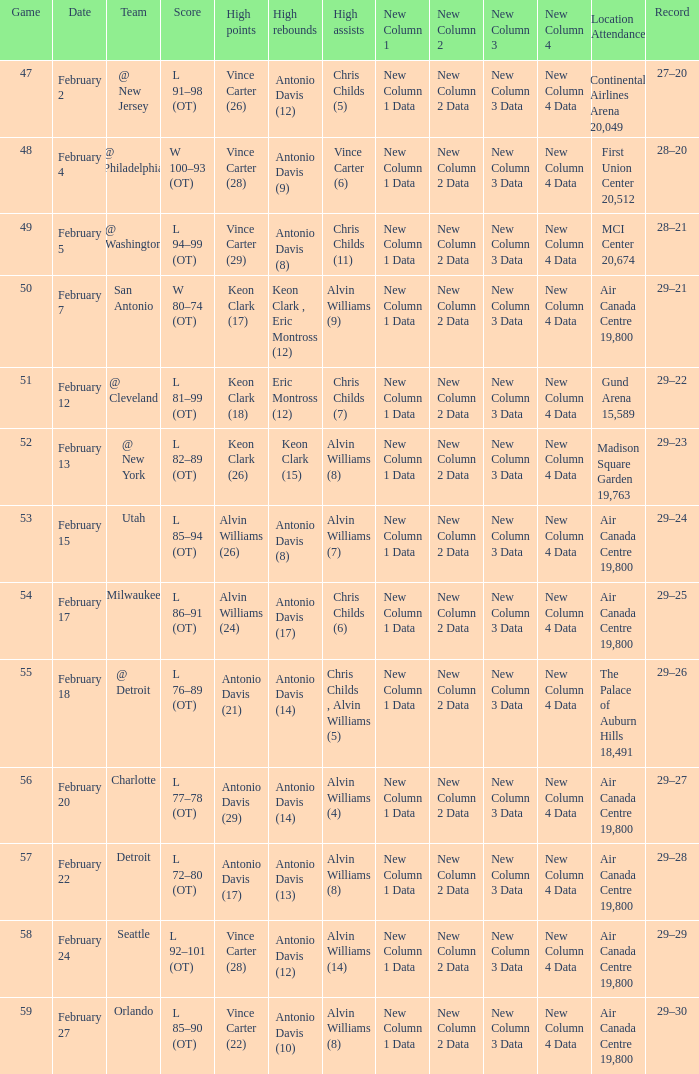What is the Record when the high rebounds was Antonio Davis (9)? 28–20. Could you parse the entire table as a dict? {'header': ['Game', 'Date', 'Team', 'Score', 'High points', 'High rebounds', 'High assists', 'New Column 1', 'New Column 2', 'New Column 3', 'New Column 4', 'Location Attendance', 'Record'], 'rows': [['47', 'February 2', '@ New Jersey', 'L 91–98 (OT)', 'Vince Carter (26)', 'Antonio Davis (12)', 'Chris Childs (5)', 'New Column 1 Data', 'New Column 2 Data', 'New Column 3 Data', 'New Column 4 Data', 'Continental Airlines Arena 20,049', '27–20'], ['48', 'February 4', '@ Philadelphia', 'W 100–93 (OT)', 'Vince Carter (28)', 'Antonio Davis (9)', 'Vince Carter (6)', 'New Column 1 Data', 'New Column 2 Data', 'New Column 3 Data', 'New Column 4 Data', 'First Union Center 20,512', '28–20'], ['49', 'February 5', '@ Washington', 'L 94–99 (OT)', 'Vince Carter (29)', 'Antonio Davis (8)', 'Chris Childs (11)', 'New Column 1 Data', 'New Column 2 Data', 'New Column 3 Data', 'New Column 4 Data', 'MCI Center 20,674', '28–21'], ['50', 'February 7', 'San Antonio', 'W 80–74 (OT)', 'Keon Clark (17)', 'Keon Clark , Eric Montross (12)', 'Alvin Williams (9)', 'New Column 1 Data', 'New Column 2 Data', 'New Column 3 Data', 'New Column 4 Data', 'Air Canada Centre 19,800', '29–21'], ['51', 'February 12', '@ Cleveland', 'L 81–99 (OT)', 'Keon Clark (18)', 'Eric Montross (12)', 'Chris Childs (7)', 'New Column 1 Data', 'New Column 2 Data', 'New Column 3 Data', 'New Column 4 Data', 'Gund Arena 15,589', '29–22'], ['52', 'February 13', '@ New York', 'L 82–89 (OT)', 'Keon Clark (26)', 'Keon Clark (15)', 'Alvin Williams (8)', 'New Column 1 Data', 'New Column 2 Data', 'New Column 3 Data', 'New Column 4 Data', 'Madison Square Garden 19,763', '29–23'], ['53', 'February 15', 'Utah', 'L 85–94 (OT)', 'Alvin Williams (26)', 'Antonio Davis (8)', 'Alvin Williams (7)', 'New Column 1 Data', 'New Column 2 Data', 'New Column 3 Data', 'New Column 4 Data', 'Air Canada Centre 19,800', '29–24'], ['54', 'February 17', 'Milwaukee', 'L 86–91 (OT)', 'Alvin Williams (24)', 'Antonio Davis (17)', 'Chris Childs (6)', 'New Column 1 Data', 'New Column 2 Data', 'New Column 3 Data', 'New Column 4 Data', 'Air Canada Centre 19,800', '29–25'], ['55', 'February 18', '@ Detroit', 'L 76–89 (OT)', 'Antonio Davis (21)', 'Antonio Davis (14)', 'Chris Childs , Alvin Williams (5)', 'New Column 1 Data', 'New Column 2 Data', 'New Column 3 Data', 'New Column 4 Data', 'The Palace of Auburn Hills 18,491', '29–26'], ['56', 'February 20', 'Charlotte', 'L 77–78 (OT)', 'Antonio Davis (29)', 'Antonio Davis (14)', 'Alvin Williams (4)', 'New Column 1 Data', 'New Column 2 Data', 'New Column 3 Data', 'New Column 4 Data', 'Air Canada Centre 19,800', '29–27'], ['57', 'February 22', 'Detroit', 'L 72–80 (OT)', 'Antonio Davis (17)', 'Antonio Davis (13)', 'Alvin Williams (8)', 'New Column 1 Data', 'New Column 2 Data', 'New Column 3 Data', 'New Column 4 Data', 'Air Canada Centre 19,800', '29–28'], ['58', 'February 24', 'Seattle', 'L 92–101 (OT)', 'Vince Carter (28)', 'Antonio Davis (12)', 'Alvin Williams (14)', 'New Column 1 Data', 'New Column 2 Data', 'New Column 3 Data', 'New Column 4 Data', 'Air Canada Centre 19,800', '29–29'], ['59', 'February 27', 'Orlando', 'L 85–90 (OT)', 'Vince Carter (22)', 'Antonio Davis (10)', 'Alvin Williams (8)', 'New Column 1 Data', 'New Column 2 Data', 'New Column 3 Data', 'New Column 4 Data', 'Air Canada Centre 19,800', '29–30']]} 